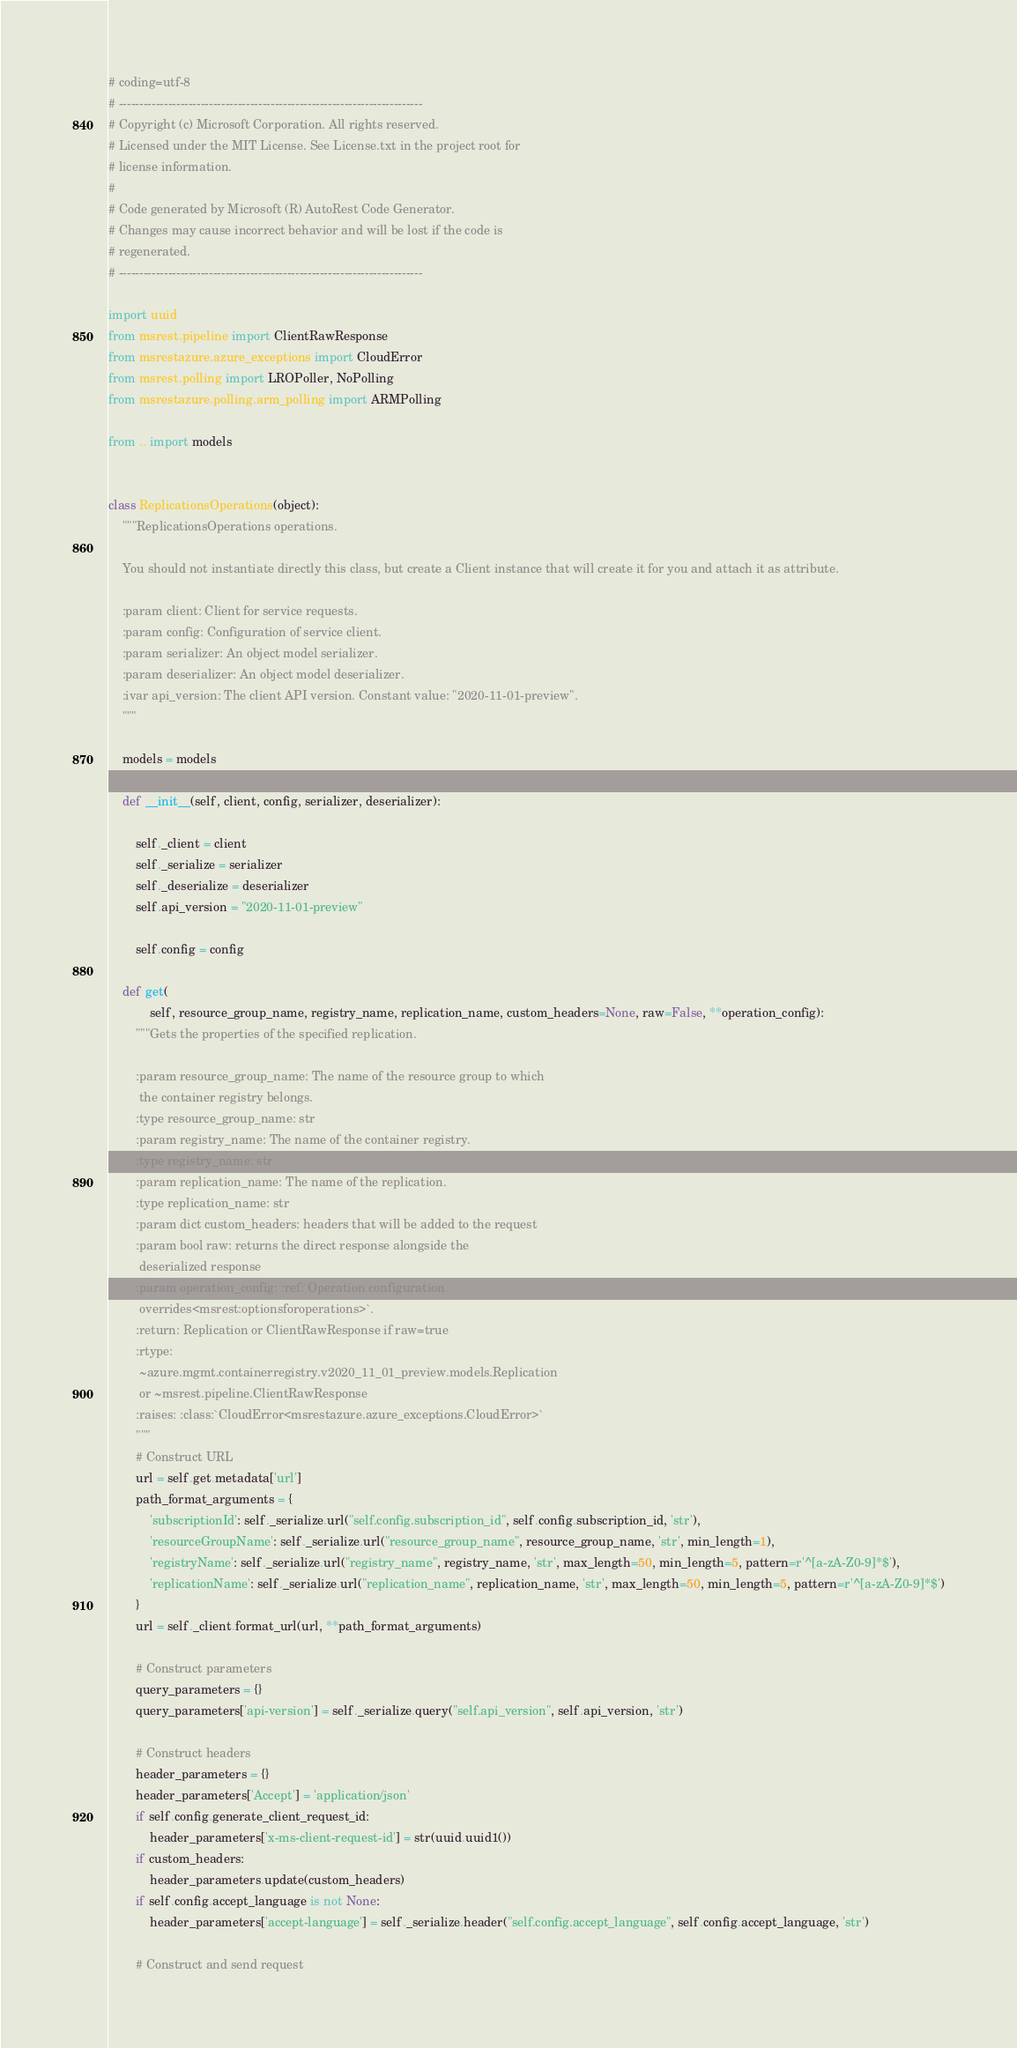Convert code to text. <code><loc_0><loc_0><loc_500><loc_500><_Python_># coding=utf-8
# --------------------------------------------------------------------------
# Copyright (c) Microsoft Corporation. All rights reserved.
# Licensed under the MIT License. See License.txt in the project root for
# license information.
#
# Code generated by Microsoft (R) AutoRest Code Generator.
# Changes may cause incorrect behavior and will be lost if the code is
# regenerated.
# --------------------------------------------------------------------------

import uuid
from msrest.pipeline import ClientRawResponse
from msrestazure.azure_exceptions import CloudError
from msrest.polling import LROPoller, NoPolling
from msrestazure.polling.arm_polling import ARMPolling

from .. import models


class ReplicationsOperations(object):
    """ReplicationsOperations operations.

    You should not instantiate directly this class, but create a Client instance that will create it for you and attach it as attribute.

    :param client: Client for service requests.
    :param config: Configuration of service client.
    :param serializer: An object model serializer.
    :param deserializer: An object model deserializer.
    :ivar api_version: The client API version. Constant value: "2020-11-01-preview".
    """

    models = models

    def __init__(self, client, config, serializer, deserializer):

        self._client = client
        self._serialize = serializer
        self._deserialize = deserializer
        self.api_version = "2020-11-01-preview"

        self.config = config

    def get(
            self, resource_group_name, registry_name, replication_name, custom_headers=None, raw=False, **operation_config):
        """Gets the properties of the specified replication.

        :param resource_group_name: The name of the resource group to which
         the container registry belongs.
        :type resource_group_name: str
        :param registry_name: The name of the container registry.
        :type registry_name: str
        :param replication_name: The name of the replication.
        :type replication_name: str
        :param dict custom_headers: headers that will be added to the request
        :param bool raw: returns the direct response alongside the
         deserialized response
        :param operation_config: :ref:`Operation configuration
         overrides<msrest:optionsforoperations>`.
        :return: Replication or ClientRawResponse if raw=true
        :rtype:
         ~azure.mgmt.containerregistry.v2020_11_01_preview.models.Replication
         or ~msrest.pipeline.ClientRawResponse
        :raises: :class:`CloudError<msrestazure.azure_exceptions.CloudError>`
        """
        # Construct URL
        url = self.get.metadata['url']
        path_format_arguments = {
            'subscriptionId': self._serialize.url("self.config.subscription_id", self.config.subscription_id, 'str'),
            'resourceGroupName': self._serialize.url("resource_group_name", resource_group_name, 'str', min_length=1),
            'registryName': self._serialize.url("registry_name", registry_name, 'str', max_length=50, min_length=5, pattern=r'^[a-zA-Z0-9]*$'),
            'replicationName': self._serialize.url("replication_name", replication_name, 'str', max_length=50, min_length=5, pattern=r'^[a-zA-Z0-9]*$')
        }
        url = self._client.format_url(url, **path_format_arguments)

        # Construct parameters
        query_parameters = {}
        query_parameters['api-version'] = self._serialize.query("self.api_version", self.api_version, 'str')

        # Construct headers
        header_parameters = {}
        header_parameters['Accept'] = 'application/json'
        if self.config.generate_client_request_id:
            header_parameters['x-ms-client-request-id'] = str(uuid.uuid1())
        if custom_headers:
            header_parameters.update(custom_headers)
        if self.config.accept_language is not None:
            header_parameters['accept-language'] = self._serialize.header("self.config.accept_language", self.config.accept_language, 'str')

        # Construct and send request</code> 